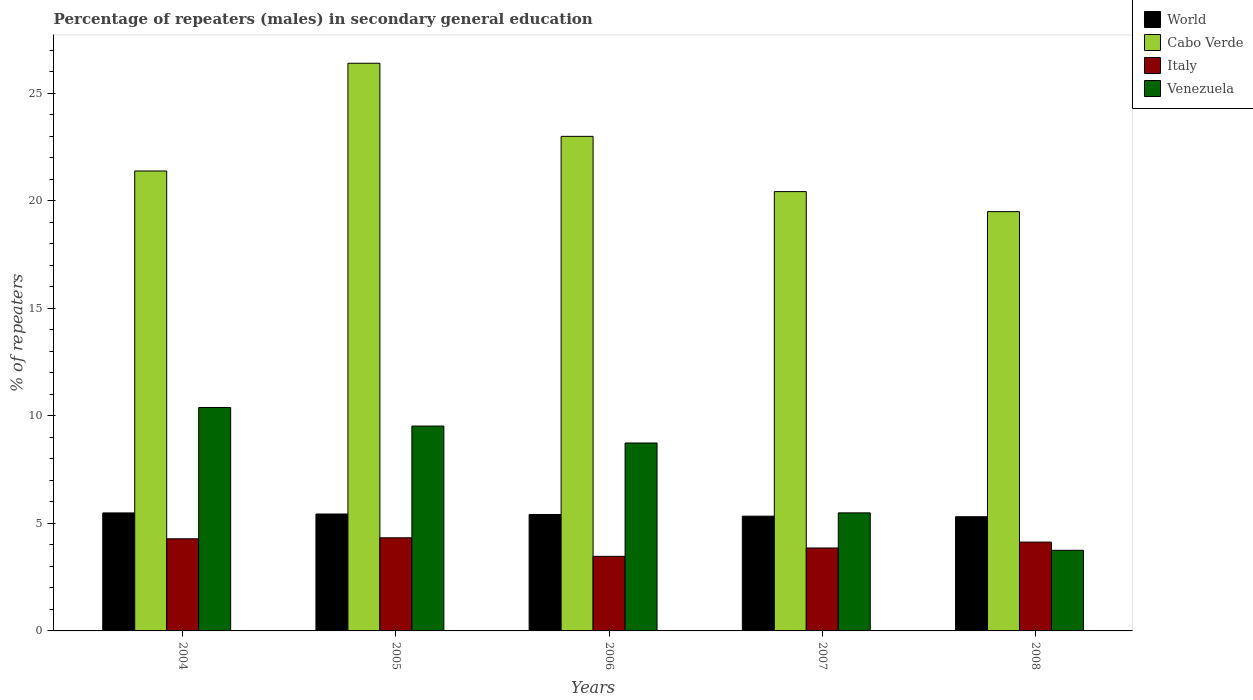How many different coloured bars are there?
Make the answer very short. 4. How many groups of bars are there?
Your answer should be very brief. 5. Are the number of bars per tick equal to the number of legend labels?
Ensure brevity in your answer.  Yes. Are the number of bars on each tick of the X-axis equal?
Offer a terse response. Yes. How many bars are there on the 1st tick from the left?
Provide a succinct answer. 4. How many bars are there on the 4th tick from the right?
Make the answer very short. 4. In how many cases, is the number of bars for a given year not equal to the number of legend labels?
Ensure brevity in your answer.  0. What is the percentage of male repeaters in Italy in 2005?
Ensure brevity in your answer.  4.33. Across all years, what is the maximum percentage of male repeaters in Cabo Verde?
Make the answer very short. 26.39. Across all years, what is the minimum percentage of male repeaters in Venezuela?
Give a very brief answer. 3.75. In which year was the percentage of male repeaters in Italy maximum?
Ensure brevity in your answer.  2005. What is the total percentage of male repeaters in Cabo Verde in the graph?
Provide a short and direct response. 110.66. What is the difference between the percentage of male repeaters in Cabo Verde in 2006 and that in 2007?
Your answer should be very brief. 2.57. What is the difference between the percentage of male repeaters in Italy in 2007 and the percentage of male repeaters in Cabo Verde in 2008?
Make the answer very short. -15.63. What is the average percentage of male repeaters in World per year?
Give a very brief answer. 5.39. In the year 2007, what is the difference between the percentage of male repeaters in Cabo Verde and percentage of male repeaters in World?
Your answer should be very brief. 15.09. In how many years, is the percentage of male repeaters in Italy greater than 11 %?
Offer a very short reply. 0. What is the ratio of the percentage of male repeaters in Cabo Verde in 2007 to that in 2008?
Make the answer very short. 1.05. What is the difference between the highest and the second highest percentage of male repeaters in Venezuela?
Ensure brevity in your answer.  0.86. What is the difference between the highest and the lowest percentage of male repeaters in World?
Make the answer very short. 0.18. In how many years, is the percentage of male repeaters in World greater than the average percentage of male repeaters in World taken over all years?
Your answer should be very brief. 3. Is it the case that in every year, the sum of the percentage of male repeaters in Cabo Verde and percentage of male repeaters in Venezuela is greater than the sum of percentage of male repeaters in World and percentage of male repeaters in Italy?
Provide a short and direct response. Yes. What does the 3rd bar from the right in 2008 represents?
Your answer should be very brief. Cabo Verde. Is it the case that in every year, the sum of the percentage of male repeaters in World and percentage of male repeaters in Italy is greater than the percentage of male repeaters in Venezuela?
Make the answer very short. No. Are all the bars in the graph horizontal?
Give a very brief answer. No. How many years are there in the graph?
Your answer should be compact. 5. What is the difference between two consecutive major ticks on the Y-axis?
Ensure brevity in your answer.  5. Does the graph contain any zero values?
Your answer should be compact. No. Does the graph contain grids?
Offer a very short reply. No. How are the legend labels stacked?
Give a very brief answer. Vertical. What is the title of the graph?
Ensure brevity in your answer.  Percentage of repeaters (males) in secondary general education. Does "Equatorial Guinea" appear as one of the legend labels in the graph?
Your answer should be very brief. No. What is the label or title of the X-axis?
Your answer should be very brief. Years. What is the label or title of the Y-axis?
Make the answer very short. % of repeaters. What is the % of repeaters in World in 2004?
Your answer should be very brief. 5.48. What is the % of repeaters of Cabo Verde in 2004?
Give a very brief answer. 21.38. What is the % of repeaters of Italy in 2004?
Your answer should be very brief. 4.28. What is the % of repeaters in Venezuela in 2004?
Your response must be concise. 10.39. What is the % of repeaters of World in 2005?
Your answer should be compact. 5.43. What is the % of repeaters in Cabo Verde in 2005?
Your answer should be compact. 26.39. What is the % of repeaters of Italy in 2005?
Ensure brevity in your answer.  4.33. What is the % of repeaters in Venezuela in 2005?
Ensure brevity in your answer.  9.52. What is the % of repeaters in World in 2006?
Offer a very short reply. 5.41. What is the % of repeaters of Cabo Verde in 2006?
Offer a terse response. 22.99. What is the % of repeaters in Italy in 2006?
Offer a very short reply. 3.47. What is the % of repeaters of Venezuela in 2006?
Ensure brevity in your answer.  8.74. What is the % of repeaters in World in 2007?
Offer a terse response. 5.33. What is the % of repeaters in Cabo Verde in 2007?
Keep it short and to the point. 20.42. What is the % of repeaters in Italy in 2007?
Offer a terse response. 3.86. What is the % of repeaters in Venezuela in 2007?
Make the answer very short. 5.49. What is the % of repeaters in World in 2008?
Provide a succinct answer. 5.31. What is the % of repeaters of Cabo Verde in 2008?
Your response must be concise. 19.49. What is the % of repeaters of Italy in 2008?
Your response must be concise. 4.13. What is the % of repeaters of Venezuela in 2008?
Offer a very short reply. 3.75. Across all years, what is the maximum % of repeaters of World?
Provide a short and direct response. 5.48. Across all years, what is the maximum % of repeaters of Cabo Verde?
Keep it short and to the point. 26.39. Across all years, what is the maximum % of repeaters in Italy?
Keep it short and to the point. 4.33. Across all years, what is the maximum % of repeaters of Venezuela?
Keep it short and to the point. 10.39. Across all years, what is the minimum % of repeaters in World?
Your answer should be compact. 5.31. Across all years, what is the minimum % of repeaters of Cabo Verde?
Offer a terse response. 19.49. Across all years, what is the minimum % of repeaters of Italy?
Provide a succinct answer. 3.47. Across all years, what is the minimum % of repeaters in Venezuela?
Your answer should be compact. 3.75. What is the total % of repeaters of World in the graph?
Offer a very short reply. 26.97. What is the total % of repeaters of Cabo Verde in the graph?
Your answer should be compact. 110.66. What is the total % of repeaters of Italy in the graph?
Provide a short and direct response. 20.06. What is the total % of repeaters of Venezuela in the graph?
Provide a short and direct response. 37.88. What is the difference between the % of repeaters of World in 2004 and that in 2005?
Keep it short and to the point. 0.05. What is the difference between the % of repeaters of Cabo Verde in 2004 and that in 2005?
Make the answer very short. -5.01. What is the difference between the % of repeaters in Italy in 2004 and that in 2005?
Offer a very short reply. -0.05. What is the difference between the % of repeaters of Venezuela in 2004 and that in 2005?
Your answer should be very brief. 0.86. What is the difference between the % of repeaters in World in 2004 and that in 2006?
Make the answer very short. 0.07. What is the difference between the % of repeaters of Cabo Verde in 2004 and that in 2006?
Ensure brevity in your answer.  -1.61. What is the difference between the % of repeaters in Italy in 2004 and that in 2006?
Keep it short and to the point. 0.82. What is the difference between the % of repeaters in Venezuela in 2004 and that in 2006?
Ensure brevity in your answer.  1.65. What is the difference between the % of repeaters of World in 2004 and that in 2007?
Offer a very short reply. 0.15. What is the difference between the % of repeaters of Cabo Verde in 2004 and that in 2007?
Provide a short and direct response. 0.96. What is the difference between the % of repeaters of Italy in 2004 and that in 2007?
Make the answer very short. 0.43. What is the difference between the % of repeaters of Venezuela in 2004 and that in 2007?
Make the answer very short. 4.9. What is the difference between the % of repeaters of World in 2004 and that in 2008?
Give a very brief answer. 0.18. What is the difference between the % of repeaters of Cabo Verde in 2004 and that in 2008?
Your answer should be compact. 1.89. What is the difference between the % of repeaters in Italy in 2004 and that in 2008?
Provide a succinct answer. 0.15. What is the difference between the % of repeaters of Venezuela in 2004 and that in 2008?
Your answer should be very brief. 6.64. What is the difference between the % of repeaters in World in 2005 and that in 2006?
Your answer should be compact. 0.02. What is the difference between the % of repeaters in Cabo Verde in 2005 and that in 2006?
Give a very brief answer. 3.4. What is the difference between the % of repeaters in Italy in 2005 and that in 2006?
Provide a short and direct response. 0.86. What is the difference between the % of repeaters in Venezuela in 2005 and that in 2006?
Offer a very short reply. 0.79. What is the difference between the % of repeaters in World in 2005 and that in 2007?
Provide a short and direct response. 0.1. What is the difference between the % of repeaters in Cabo Verde in 2005 and that in 2007?
Provide a succinct answer. 5.97. What is the difference between the % of repeaters in Italy in 2005 and that in 2007?
Provide a short and direct response. 0.47. What is the difference between the % of repeaters in Venezuela in 2005 and that in 2007?
Your response must be concise. 4.04. What is the difference between the % of repeaters of World in 2005 and that in 2008?
Provide a short and direct response. 0.13. What is the difference between the % of repeaters in Cabo Verde in 2005 and that in 2008?
Provide a succinct answer. 6.9. What is the difference between the % of repeaters in Italy in 2005 and that in 2008?
Provide a succinct answer. 0.2. What is the difference between the % of repeaters in Venezuela in 2005 and that in 2008?
Your response must be concise. 5.78. What is the difference between the % of repeaters of World in 2006 and that in 2007?
Your answer should be very brief. 0.08. What is the difference between the % of repeaters of Cabo Verde in 2006 and that in 2007?
Keep it short and to the point. 2.57. What is the difference between the % of repeaters in Italy in 2006 and that in 2007?
Your answer should be compact. -0.39. What is the difference between the % of repeaters of Venezuela in 2006 and that in 2007?
Offer a very short reply. 3.25. What is the difference between the % of repeaters of World in 2006 and that in 2008?
Your answer should be very brief. 0.1. What is the difference between the % of repeaters of Cabo Verde in 2006 and that in 2008?
Your answer should be compact. 3.5. What is the difference between the % of repeaters of Italy in 2006 and that in 2008?
Your answer should be compact. -0.66. What is the difference between the % of repeaters in Venezuela in 2006 and that in 2008?
Your answer should be very brief. 4.99. What is the difference between the % of repeaters of World in 2007 and that in 2008?
Offer a terse response. 0.03. What is the difference between the % of repeaters in Italy in 2007 and that in 2008?
Offer a very short reply. -0.27. What is the difference between the % of repeaters in Venezuela in 2007 and that in 2008?
Offer a terse response. 1.74. What is the difference between the % of repeaters in World in 2004 and the % of repeaters in Cabo Verde in 2005?
Give a very brief answer. -20.9. What is the difference between the % of repeaters in World in 2004 and the % of repeaters in Italy in 2005?
Provide a short and direct response. 1.16. What is the difference between the % of repeaters of World in 2004 and the % of repeaters of Venezuela in 2005?
Ensure brevity in your answer.  -4.04. What is the difference between the % of repeaters of Cabo Verde in 2004 and the % of repeaters of Italy in 2005?
Your answer should be very brief. 17.05. What is the difference between the % of repeaters of Cabo Verde in 2004 and the % of repeaters of Venezuela in 2005?
Ensure brevity in your answer.  11.86. What is the difference between the % of repeaters in Italy in 2004 and the % of repeaters in Venezuela in 2005?
Offer a terse response. -5.24. What is the difference between the % of repeaters of World in 2004 and the % of repeaters of Cabo Verde in 2006?
Make the answer very short. -17.5. What is the difference between the % of repeaters in World in 2004 and the % of repeaters in Italy in 2006?
Your answer should be very brief. 2.02. What is the difference between the % of repeaters in World in 2004 and the % of repeaters in Venezuela in 2006?
Ensure brevity in your answer.  -3.25. What is the difference between the % of repeaters of Cabo Verde in 2004 and the % of repeaters of Italy in 2006?
Provide a short and direct response. 17.91. What is the difference between the % of repeaters in Cabo Verde in 2004 and the % of repeaters in Venezuela in 2006?
Give a very brief answer. 12.64. What is the difference between the % of repeaters of Italy in 2004 and the % of repeaters of Venezuela in 2006?
Your answer should be compact. -4.45. What is the difference between the % of repeaters in World in 2004 and the % of repeaters in Cabo Verde in 2007?
Offer a terse response. -14.94. What is the difference between the % of repeaters of World in 2004 and the % of repeaters of Italy in 2007?
Provide a short and direct response. 1.63. What is the difference between the % of repeaters of World in 2004 and the % of repeaters of Venezuela in 2007?
Provide a short and direct response. -0. What is the difference between the % of repeaters of Cabo Verde in 2004 and the % of repeaters of Italy in 2007?
Ensure brevity in your answer.  17.52. What is the difference between the % of repeaters of Cabo Verde in 2004 and the % of repeaters of Venezuela in 2007?
Make the answer very short. 15.89. What is the difference between the % of repeaters in Italy in 2004 and the % of repeaters in Venezuela in 2007?
Ensure brevity in your answer.  -1.2. What is the difference between the % of repeaters in World in 2004 and the % of repeaters in Cabo Verde in 2008?
Offer a very short reply. -14. What is the difference between the % of repeaters of World in 2004 and the % of repeaters of Italy in 2008?
Make the answer very short. 1.36. What is the difference between the % of repeaters in World in 2004 and the % of repeaters in Venezuela in 2008?
Keep it short and to the point. 1.74. What is the difference between the % of repeaters in Cabo Verde in 2004 and the % of repeaters in Italy in 2008?
Provide a succinct answer. 17.25. What is the difference between the % of repeaters in Cabo Verde in 2004 and the % of repeaters in Venezuela in 2008?
Your answer should be very brief. 17.63. What is the difference between the % of repeaters of Italy in 2004 and the % of repeaters of Venezuela in 2008?
Ensure brevity in your answer.  0.54. What is the difference between the % of repeaters in World in 2005 and the % of repeaters in Cabo Verde in 2006?
Provide a succinct answer. -17.55. What is the difference between the % of repeaters of World in 2005 and the % of repeaters of Italy in 2006?
Provide a short and direct response. 1.97. What is the difference between the % of repeaters in World in 2005 and the % of repeaters in Venezuela in 2006?
Provide a succinct answer. -3.3. What is the difference between the % of repeaters of Cabo Verde in 2005 and the % of repeaters of Italy in 2006?
Keep it short and to the point. 22.92. What is the difference between the % of repeaters in Cabo Verde in 2005 and the % of repeaters in Venezuela in 2006?
Offer a very short reply. 17.65. What is the difference between the % of repeaters in Italy in 2005 and the % of repeaters in Venezuela in 2006?
Ensure brevity in your answer.  -4.41. What is the difference between the % of repeaters of World in 2005 and the % of repeaters of Cabo Verde in 2007?
Give a very brief answer. -14.99. What is the difference between the % of repeaters in World in 2005 and the % of repeaters in Italy in 2007?
Offer a very short reply. 1.58. What is the difference between the % of repeaters in World in 2005 and the % of repeaters in Venezuela in 2007?
Your answer should be very brief. -0.05. What is the difference between the % of repeaters of Cabo Verde in 2005 and the % of repeaters of Italy in 2007?
Your response must be concise. 22.53. What is the difference between the % of repeaters in Cabo Verde in 2005 and the % of repeaters in Venezuela in 2007?
Your answer should be compact. 20.9. What is the difference between the % of repeaters of Italy in 2005 and the % of repeaters of Venezuela in 2007?
Provide a short and direct response. -1.16. What is the difference between the % of repeaters of World in 2005 and the % of repeaters of Cabo Verde in 2008?
Your answer should be very brief. -14.06. What is the difference between the % of repeaters in World in 2005 and the % of repeaters in Italy in 2008?
Your answer should be very brief. 1.31. What is the difference between the % of repeaters in World in 2005 and the % of repeaters in Venezuela in 2008?
Provide a succinct answer. 1.69. What is the difference between the % of repeaters in Cabo Verde in 2005 and the % of repeaters in Italy in 2008?
Offer a very short reply. 22.26. What is the difference between the % of repeaters of Cabo Verde in 2005 and the % of repeaters of Venezuela in 2008?
Your response must be concise. 22.64. What is the difference between the % of repeaters in Italy in 2005 and the % of repeaters in Venezuela in 2008?
Your answer should be very brief. 0.58. What is the difference between the % of repeaters in World in 2006 and the % of repeaters in Cabo Verde in 2007?
Ensure brevity in your answer.  -15.01. What is the difference between the % of repeaters of World in 2006 and the % of repeaters of Italy in 2007?
Your answer should be compact. 1.56. What is the difference between the % of repeaters of World in 2006 and the % of repeaters of Venezuela in 2007?
Ensure brevity in your answer.  -0.07. What is the difference between the % of repeaters of Cabo Verde in 2006 and the % of repeaters of Italy in 2007?
Give a very brief answer. 19.13. What is the difference between the % of repeaters in Cabo Verde in 2006 and the % of repeaters in Venezuela in 2007?
Your answer should be compact. 17.5. What is the difference between the % of repeaters of Italy in 2006 and the % of repeaters of Venezuela in 2007?
Provide a short and direct response. -2.02. What is the difference between the % of repeaters of World in 2006 and the % of repeaters of Cabo Verde in 2008?
Your response must be concise. -14.08. What is the difference between the % of repeaters of World in 2006 and the % of repeaters of Italy in 2008?
Offer a terse response. 1.28. What is the difference between the % of repeaters of World in 2006 and the % of repeaters of Venezuela in 2008?
Offer a very short reply. 1.67. What is the difference between the % of repeaters in Cabo Verde in 2006 and the % of repeaters in Italy in 2008?
Provide a short and direct response. 18.86. What is the difference between the % of repeaters in Cabo Verde in 2006 and the % of repeaters in Venezuela in 2008?
Make the answer very short. 19.24. What is the difference between the % of repeaters of Italy in 2006 and the % of repeaters of Venezuela in 2008?
Ensure brevity in your answer.  -0.28. What is the difference between the % of repeaters of World in 2007 and the % of repeaters of Cabo Verde in 2008?
Offer a terse response. -14.16. What is the difference between the % of repeaters in World in 2007 and the % of repeaters in Italy in 2008?
Give a very brief answer. 1.2. What is the difference between the % of repeaters of World in 2007 and the % of repeaters of Venezuela in 2008?
Offer a very short reply. 1.59. What is the difference between the % of repeaters of Cabo Verde in 2007 and the % of repeaters of Italy in 2008?
Your response must be concise. 16.29. What is the difference between the % of repeaters of Cabo Verde in 2007 and the % of repeaters of Venezuela in 2008?
Your answer should be very brief. 16.67. What is the difference between the % of repeaters of Italy in 2007 and the % of repeaters of Venezuela in 2008?
Your response must be concise. 0.11. What is the average % of repeaters in World per year?
Keep it short and to the point. 5.39. What is the average % of repeaters of Cabo Verde per year?
Your response must be concise. 22.13. What is the average % of repeaters of Italy per year?
Your answer should be very brief. 4.01. What is the average % of repeaters of Venezuela per year?
Make the answer very short. 7.58. In the year 2004, what is the difference between the % of repeaters in World and % of repeaters in Cabo Verde?
Give a very brief answer. -15.89. In the year 2004, what is the difference between the % of repeaters of World and % of repeaters of Italy?
Ensure brevity in your answer.  1.2. In the year 2004, what is the difference between the % of repeaters in World and % of repeaters in Venezuela?
Ensure brevity in your answer.  -4.9. In the year 2004, what is the difference between the % of repeaters in Cabo Verde and % of repeaters in Italy?
Give a very brief answer. 17.1. In the year 2004, what is the difference between the % of repeaters in Cabo Verde and % of repeaters in Venezuela?
Provide a succinct answer. 10.99. In the year 2004, what is the difference between the % of repeaters of Italy and % of repeaters of Venezuela?
Ensure brevity in your answer.  -6.1. In the year 2005, what is the difference between the % of repeaters of World and % of repeaters of Cabo Verde?
Your response must be concise. -20.95. In the year 2005, what is the difference between the % of repeaters in World and % of repeaters in Italy?
Your answer should be compact. 1.11. In the year 2005, what is the difference between the % of repeaters of World and % of repeaters of Venezuela?
Keep it short and to the point. -4.09. In the year 2005, what is the difference between the % of repeaters in Cabo Verde and % of repeaters in Italy?
Make the answer very short. 22.06. In the year 2005, what is the difference between the % of repeaters in Cabo Verde and % of repeaters in Venezuela?
Provide a short and direct response. 16.86. In the year 2005, what is the difference between the % of repeaters of Italy and % of repeaters of Venezuela?
Ensure brevity in your answer.  -5.19. In the year 2006, what is the difference between the % of repeaters in World and % of repeaters in Cabo Verde?
Keep it short and to the point. -17.58. In the year 2006, what is the difference between the % of repeaters of World and % of repeaters of Italy?
Your answer should be very brief. 1.95. In the year 2006, what is the difference between the % of repeaters in World and % of repeaters in Venezuela?
Ensure brevity in your answer.  -3.32. In the year 2006, what is the difference between the % of repeaters of Cabo Verde and % of repeaters of Italy?
Offer a terse response. 19.52. In the year 2006, what is the difference between the % of repeaters in Cabo Verde and % of repeaters in Venezuela?
Offer a terse response. 14.25. In the year 2006, what is the difference between the % of repeaters in Italy and % of repeaters in Venezuela?
Give a very brief answer. -5.27. In the year 2007, what is the difference between the % of repeaters in World and % of repeaters in Cabo Verde?
Give a very brief answer. -15.09. In the year 2007, what is the difference between the % of repeaters in World and % of repeaters in Italy?
Offer a very short reply. 1.48. In the year 2007, what is the difference between the % of repeaters of World and % of repeaters of Venezuela?
Provide a short and direct response. -0.15. In the year 2007, what is the difference between the % of repeaters of Cabo Verde and % of repeaters of Italy?
Your answer should be compact. 16.56. In the year 2007, what is the difference between the % of repeaters of Cabo Verde and % of repeaters of Venezuela?
Your answer should be compact. 14.93. In the year 2007, what is the difference between the % of repeaters of Italy and % of repeaters of Venezuela?
Give a very brief answer. -1.63. In the year 2008, what is the difference between the % of repeaters in World and % of repeaters in Cabo Verde?
Make the answer very short. -14.18. In the year 2008, what is the difference between the % of repeaters in World and % of repeaters in Italy?
Offer a very short reply. 1.18. In the year 2008, what is the difference between the % of repeaters in World and % of repeaters in Venezuela?
Make the answer very short. 1.56. In the year 2008, what is the difference between the % of repeaters in Cabo Verde and % of repeaters in Italy?
Make the answer very short. 15.36. In the year 2008, what is the difference between the % of repeaters of Cabo Verde and % of repeaters of Venezuela?
Give a very brief answer. 15.74. In the year 2008, what is the difference between the % of repeaters in Italy and % of repeaters in Venezuela?
Offer a terse response. 0.38. What is the ratio of the % of repeaters of World in 2004 to that in 2005?
Provide a short and direct response. 1.01. What is the ratio of the % of repeaters in Cabo Verde in 2004 to that in 2005?
Your answer should be compact. 0.81. What is the ratio of the % of repeaters of Italy in 2004 to that in 2005?
Give a very brief answer. 0.99. What is the ratio of the % of repeaters in Venezuela in 2004 to that in 2005?
Provide a short and direct response. 1.09. What is the ratio of the % of repeaters in World in 2004 to that in 2006?
Your response must be concise. 1.01. What is the ratio of the % of repeaters in Cabo Verde in 2004 to that in 2006?
Offer a very short reply. 0.93. What is the ratio of the % of repeaters in Italy in 2004 to that in 2006?
Your response must be concise. 1.24. What is the ratio of the % of repeaters in Venezuela in 2004 to that in 2006?
Keep it short and to the point. 1.19. What is the ratio of the % of repeaters of World in 2004 to that in 2007?
Offer a very short reply. 1.03. What is the ratio of the % of repeaters of Cabo Verde in 2004 to that in 2007?
Your answer should be compact. 1.05. What is the ratio of the % of repeaters of Italy in 2004 to that in 2007?
Make the answer very short. 1.11. What is the ratio of the % of repeaters of Venezuela in 2004 to that in 2007?
Keep it short and to the point. 1.89. What is the ratio of the % of repeaters of World in 2004 to that in 2008?
Provide a short and direct response. 1.03. What is the ratio of the % of repeaters of Cabo Verde in 2004 to that in 2008?
Your response must be concise. 1.1. What is the ratio of the % of repeaters of Italy in 2004 to that in 2008?
Give a very brief answer. 1.04. What is the ratio of the % of repeaters in Venezuela in 2004 to that in 2008?
Make the answer very short. 2.77. What is the ratio of the % of repeaters of World in 2005 to that in 2006?
Give a very brief answer. 1. What is the ratio of the % of repeaters of Cabo Verde in 2005 to that in 2006?
Offer a very short reply. 1.15. What is the ratio of the % of repeaters of Italy in 2005 to that in 2006?
Your response must be concise. 1.25. What is the ratio of the % of repeaters of Venezuela in 2005 to that in 2006?
Make the answer very short. 1.09. What is the ratio of the % of repeaters in World in 2005 to that in 2007?
Provide a short and direct response. 1.02. What is the ratio of the % of repeaters in Cabo Verde in 2005 to that in 2007?
Your response must be concise. 1.29. What is the ratio of the % of repeaters in Italy in 2005 to that in 2007?
Provide a short and direct response. 1.12. What is the ratio of the % of repeaters of Venezuela in 2005 to that in 2007?
Make the answer very short. 1.74. What is the ratio of the % of repeaters of World in 2005 to that in 2008?
Offer a very short reply. 1.02. What is the ratio of the % of repeaters of Cabo Verde in 2005 to that in 2008?
Provide a succinct answer. 1.35. What is the ratio of the % of repeaters in Italy in 2005 to that in 2008?
Offer a terse response. 1.05. What is the ratio of the % of repeaters of Venezuela in 2005 to that in 2008?
Ensure brevity in your answer.  2.54. What is the ratio of the % of repeaters of World in 2006 to that in 2007?
Keep it short and to the point. 1.01. What is the ratio of the % of repeaters in Cabo Verde in 2006 to that in 2007?
Your answer should be very brief. 1.13. What is the ratio of the % of repeaters in Italy in 2006 to that in 2007?
Ensure brevity in your answer.  0.9. What is the ratio of the % of repeaters of Venezuela in 2006 to that in 2007?
Give a very brief answer. 1.59. What is the ratio of the % of repeaters of World in 2006 to that in 2008?
Your answer should be very brief. 1.02. What is the ratio of the % of repeaters in Cabo Verde in 2006 to that in 2008?
Your response must be concise. 1.18. What is the ratio of the % of repeaters of Italy in 2006 to that in 2008?
Keep it short and to the point. 0.84. What is the ratio of the % of repeaters of Venezuela in 2006 to that in 2008?
Offer a very short reply. 2.33. What is the ratio of the % of repeaters of Cabo Verde in 2007 to that in 2008?
Your answer should be very brief. 1.05. What is the ratio of the % of repeaters in Italy in 2007 to that in 2008?
Provide a short and direct response. 0.93. What is the ratio of the % of repeaters in Venezuela in 2007 to that in 2008?
Your response must be concise. 1.46. What is the difference between the highest and the second highest % of repeaters in World?
Make the answer very short. 0.05. What is the difference between the highest and the second highest % of repeaters in Cabo Verde?
Provide a short and direct response. 3.4. What is the difference between the highest and the second highest % of repeaters in Italy?
Your answer should be very brief. 0.05. What is the difference between the highest and the second highest % of repeaters in Venezuela?
Offer a very short reply. 0.86. What is the difference between the highest and the lowest % of repeaters in World?
Your answer should be compact. 0.18. What is the difference between the highest and the lowest % of repeaters of Cabo Verde?
Your response must be concise. 6.9. What is the difference between the highest and the lowest % of repeaters of Italy?
Offer a terse response. 0.86. What is the difference between the highest and the lowest % of repeaters of Venezuela?
Ensure brevity in your answer.  6.64. 